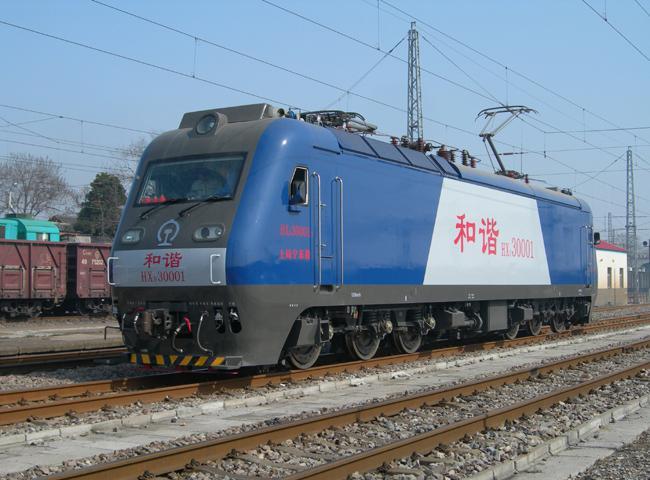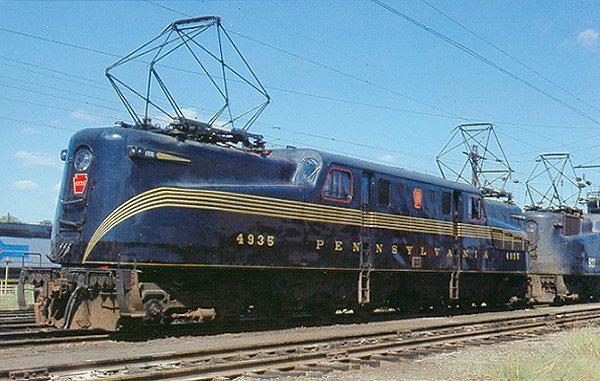The first image is the image on the left, the second image is the image on the right. Given the left and right images, does the statement "In the leftmost image the train is blue with red chinese lettering." hold true? Answer yes or no. Yes. The first image is the image on the left, the second image is the image on the right. Examine the images to the left and right. Is the description "The images show blue trains heading leftward." accurate? Answer yes or no. Yes. 